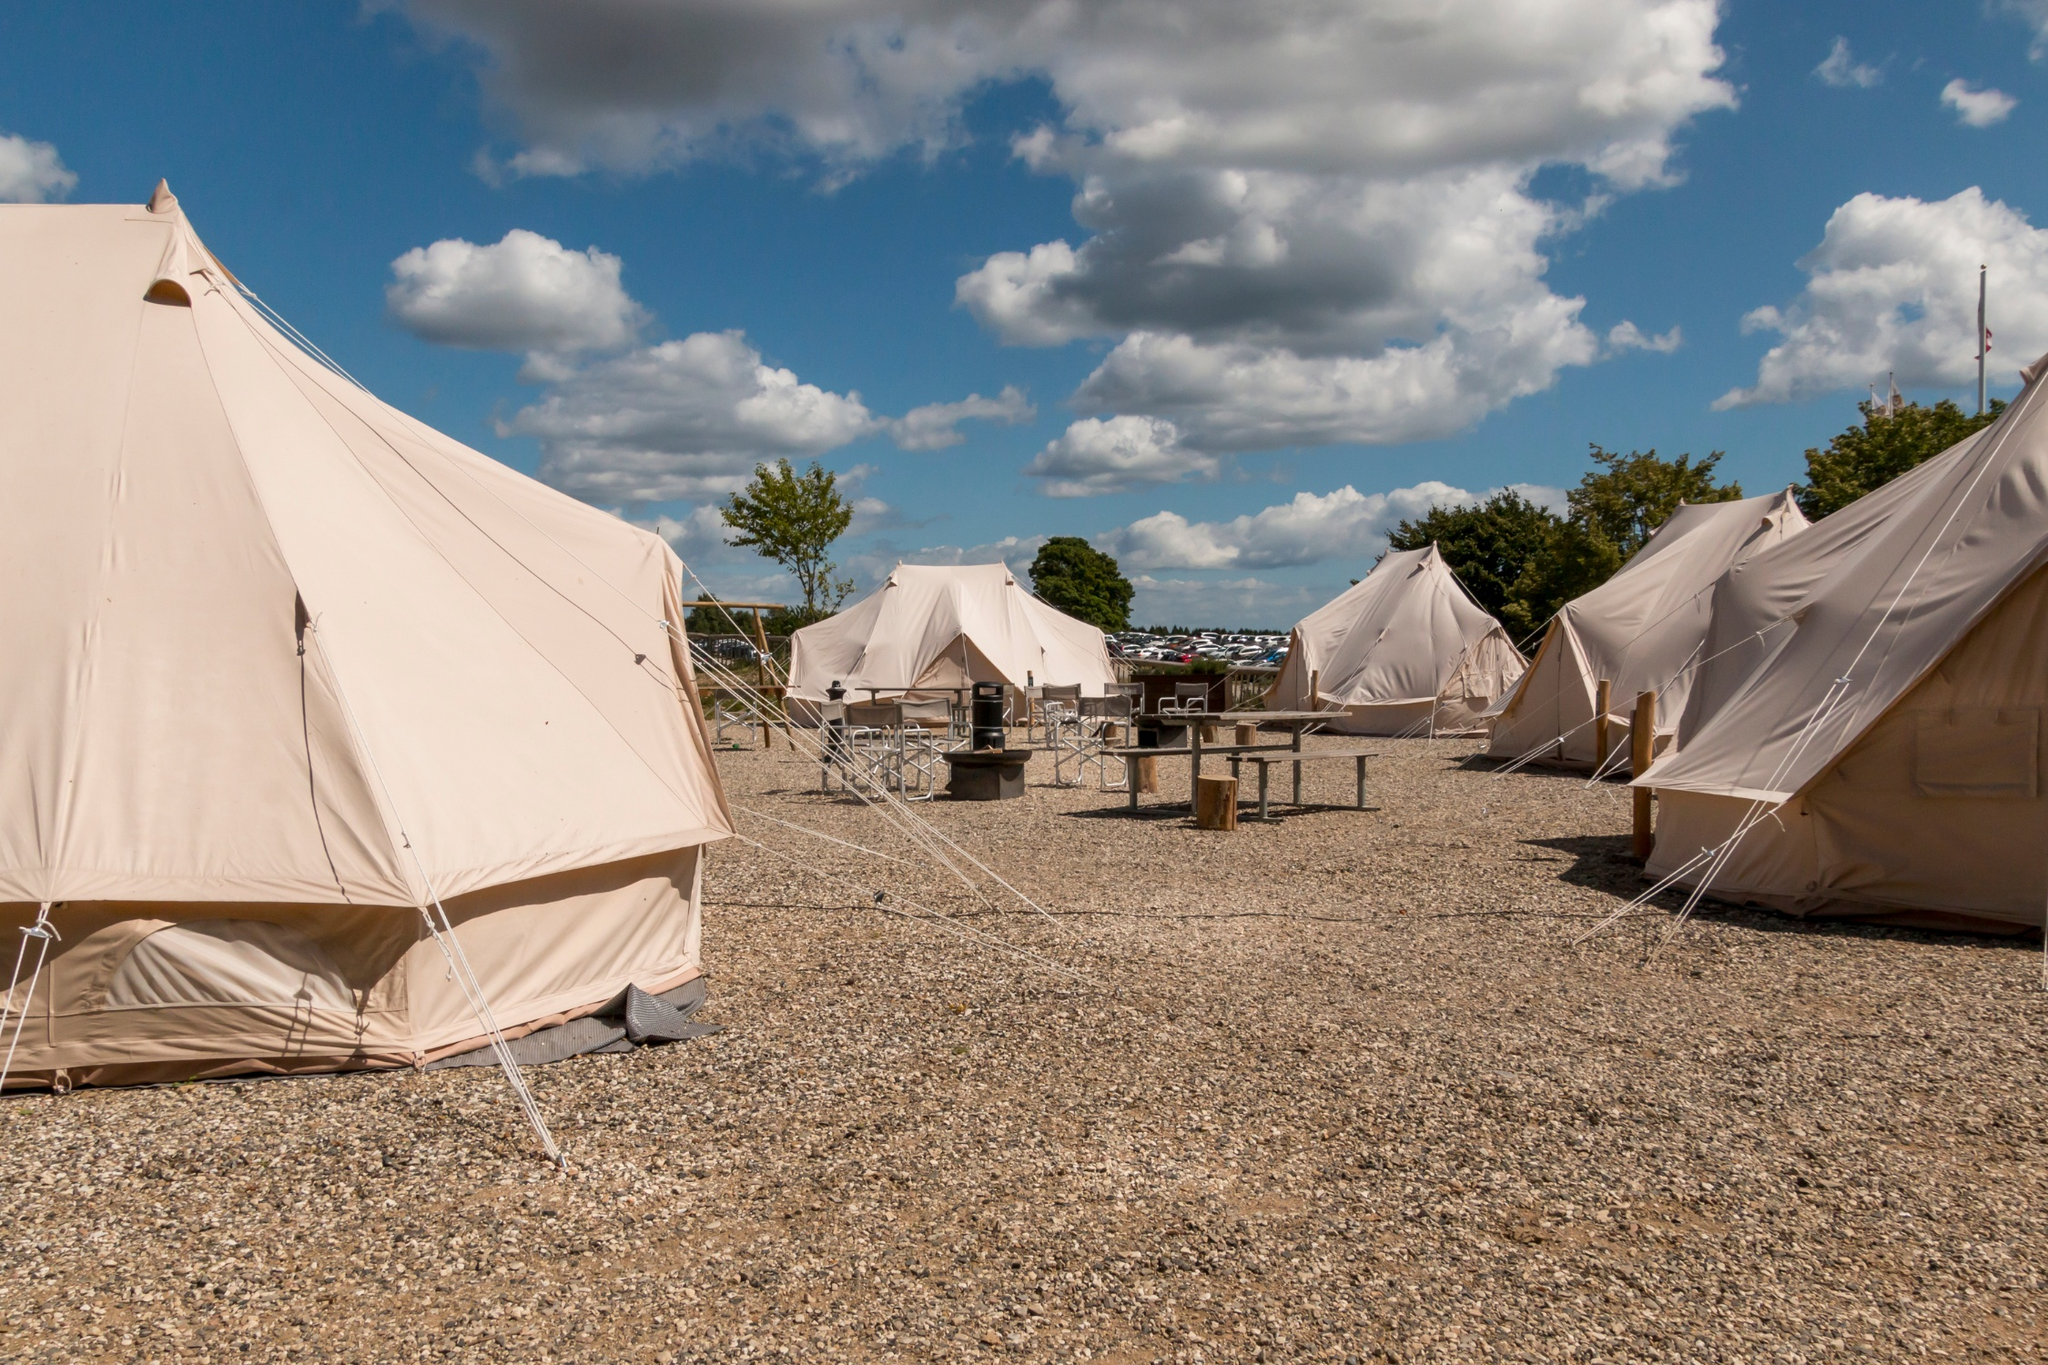What is this photo about'? This photo showcases a tranquil campsite set in a scenic outdoor environment. The center of attention is several large beige tents arranged thoughtfully in a semi-circle, creating a sense of unity among the campers. In the middle is a sturdy wooden table with benches, inviting campers to dine, converse, and mingle. The ground is covered in a layer of gravel, enhancing the natural, rustic feel of the scene.

Above, the blue sky is dotted with fluffy white clouds, suggesting a pleasant weather ideal for outdoor activities. The backdrop of tall trees adds to the feeling of seclusion and connection with nature. This idyllic setting offers an escape from urban life, providing an opportunity to relax and enjoy the beauty of the wilderness. 